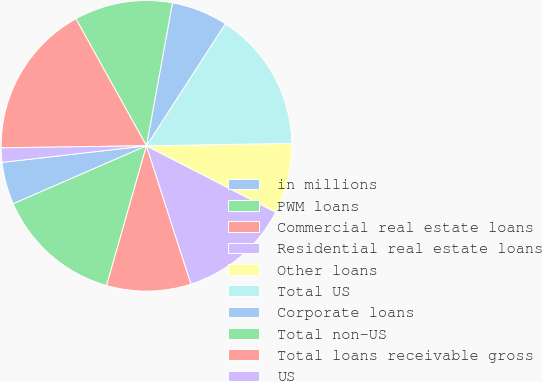Convert chart to OTSL. <chart><loc_0><loc_0><loc_500><loc_500><pie_chart><fcel>in millions<fcel>PWM loans<fcel>Commercial real estate loans<fcel>Residential real estate loans<fcel>Other loans<fcel>Total US<fcel>Corporate loans<fcel>Total non-US<fcel>Total loans receivable gross<fcel>US<nl><fcel>4.71%<fcel>14.04%<fcel>9.38%<fcel>12.49%<fcel>7.82%<fcel>15.6%<fcel>6.27%<fcel>10.93%<fcel>17.15%<fcel>1.6%<nl></chart> 